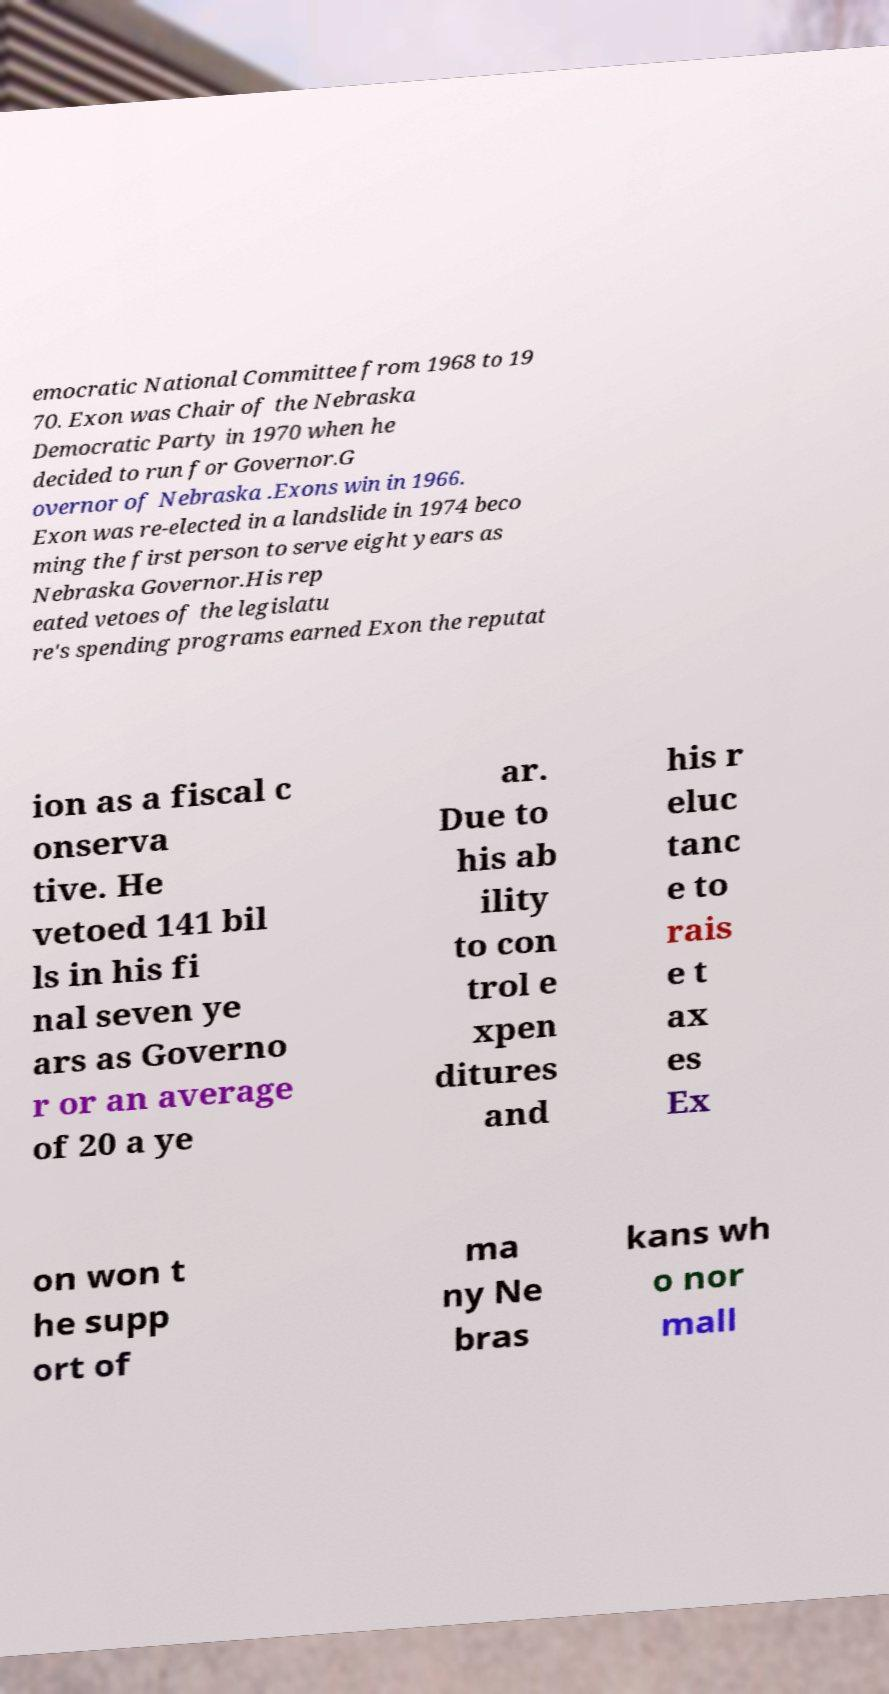Could you assist in decoding the text presented in this image and type it out clearly? emocratic National Committee from 1968 to 19 70. Exon was Chair of the Nebraska Democratic Party in 1970 when he decided to run for Governor.G overnor of Nebraska .Exons win in 1966. Exon was re-elected in a landslide in 1974 beco ming the first person to serve eight years as Nebraska Governor.His rep eated vetoes of the legislatu re's spending programs earned Exon the reputat ion as a fiscal c onserva tive. He vetoed 141 bil ls in his fi nal seven ye ars as Governo r or an average of 20 a ye ar. Due to his ab ility to con trol e xpen ditures and his r eluc tanc e to rais e t ax es Ex on won t he supp ort of ma ny Ne bras kans wh o nor mall 